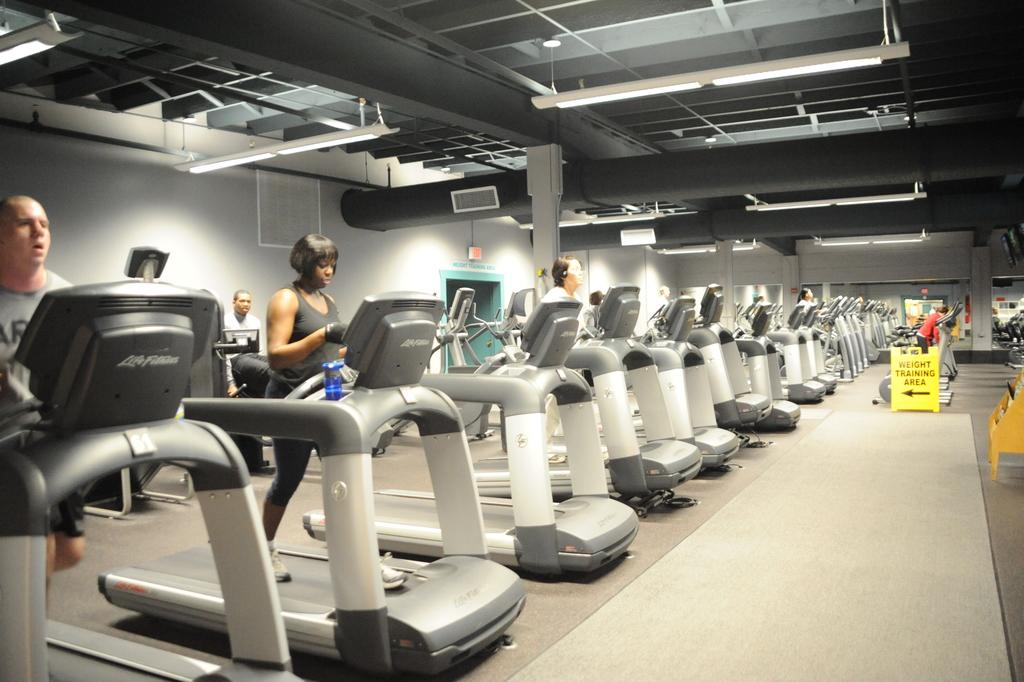What are the people in the image doing? The people in the image are on a treadmill. What can be seen attached to the roof in the image? There are lights attached to the roof in the image. What is the purpose of the sign board in the image? The purpose of the sign board in the image is not specified, but it could be providing information or directions. What type of flower is the stranger holding in the image? There is no flower or stranger present in the image. 